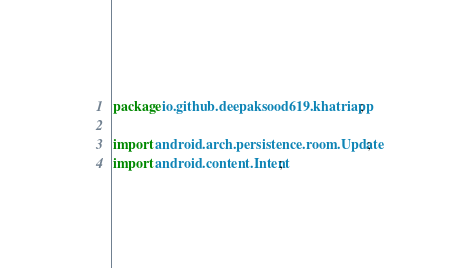<code> <loc_0><loc_0><loc_500><loc_500><_Java_>package io.github.deepaksood619.khatriapp;

import android.arch.persistence.room.Update;
import android.content.Intent;</code> 